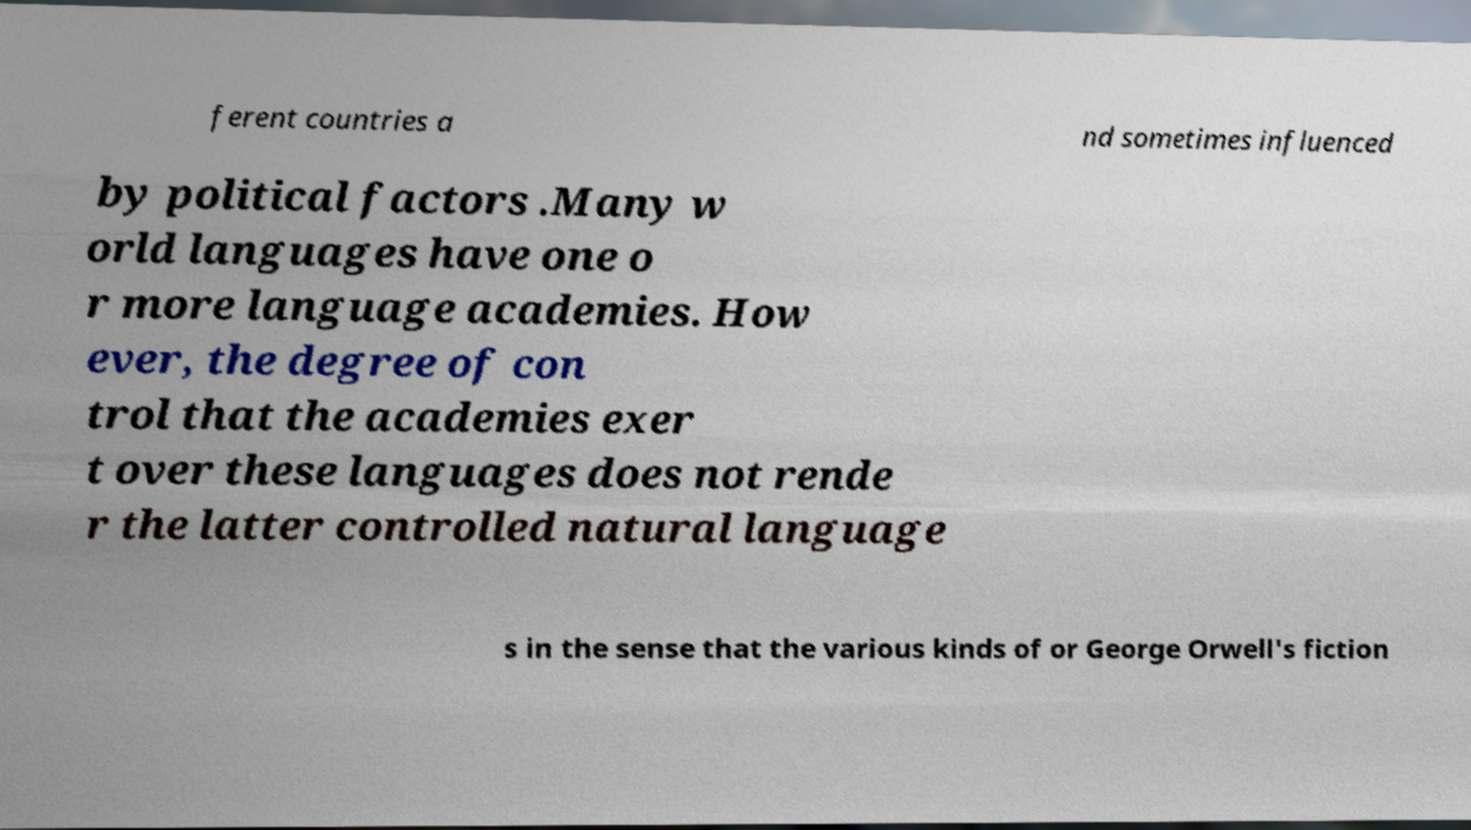Can you read and provide the text displayed in the image?This photo seems to have some interesting text. Can you extract and type it out for me? ferent countries a nd sometimes influenced by political factors .Many w orld languages have one o r more language academies. How ever, the degree of con trol that the academies exer t over these languages does not rende r the latter controlled natural language s in the sense that the various kinds of or George Orwell's fiction 